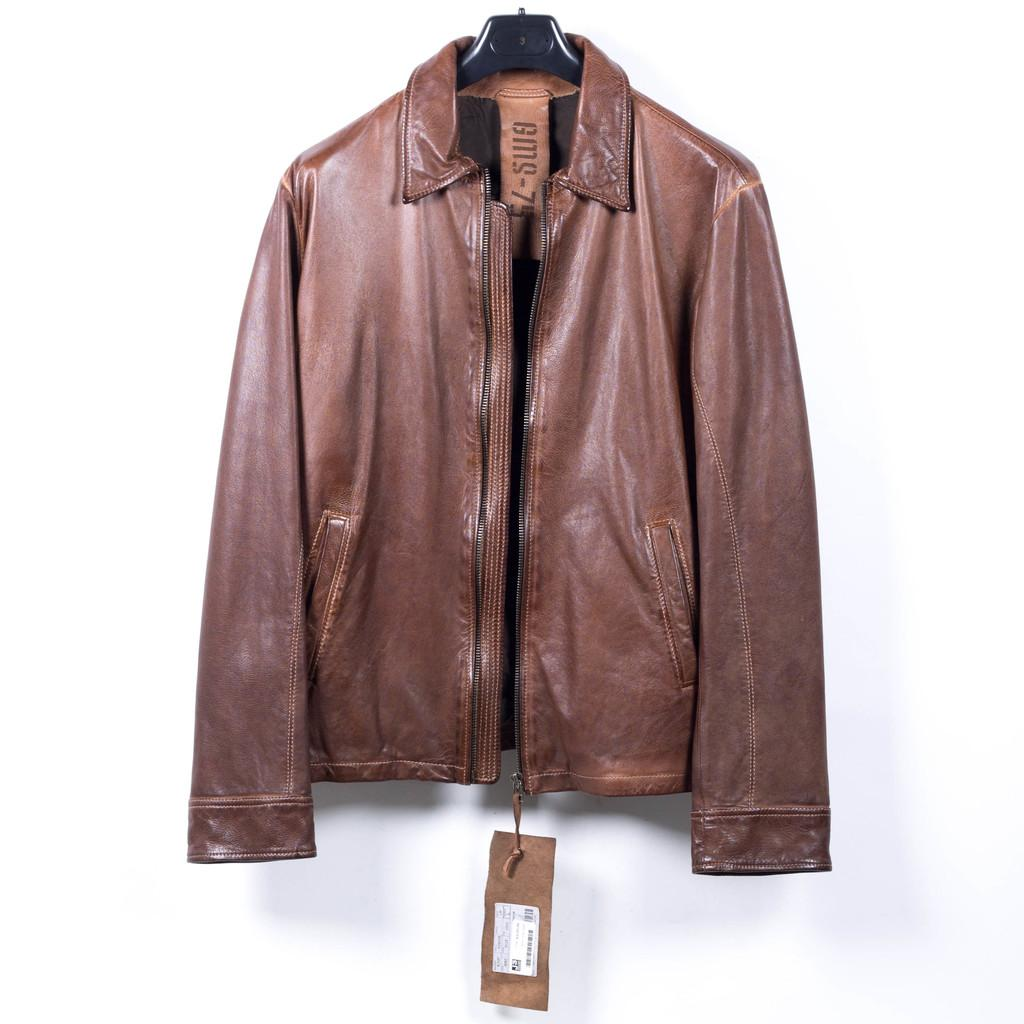What color is the jacket in the image? The jacket in the image is brown. How is the jacket positioned in the image? The jacket is hanging on a hanger. What can be seen behind the jacket in the image? There is a white wall in the background of the image. Can you see any pickles on the hanger with the jacket? There are no pickles present in the image; it only features a brown jacket hanging on a hanger in front of a white wall. 